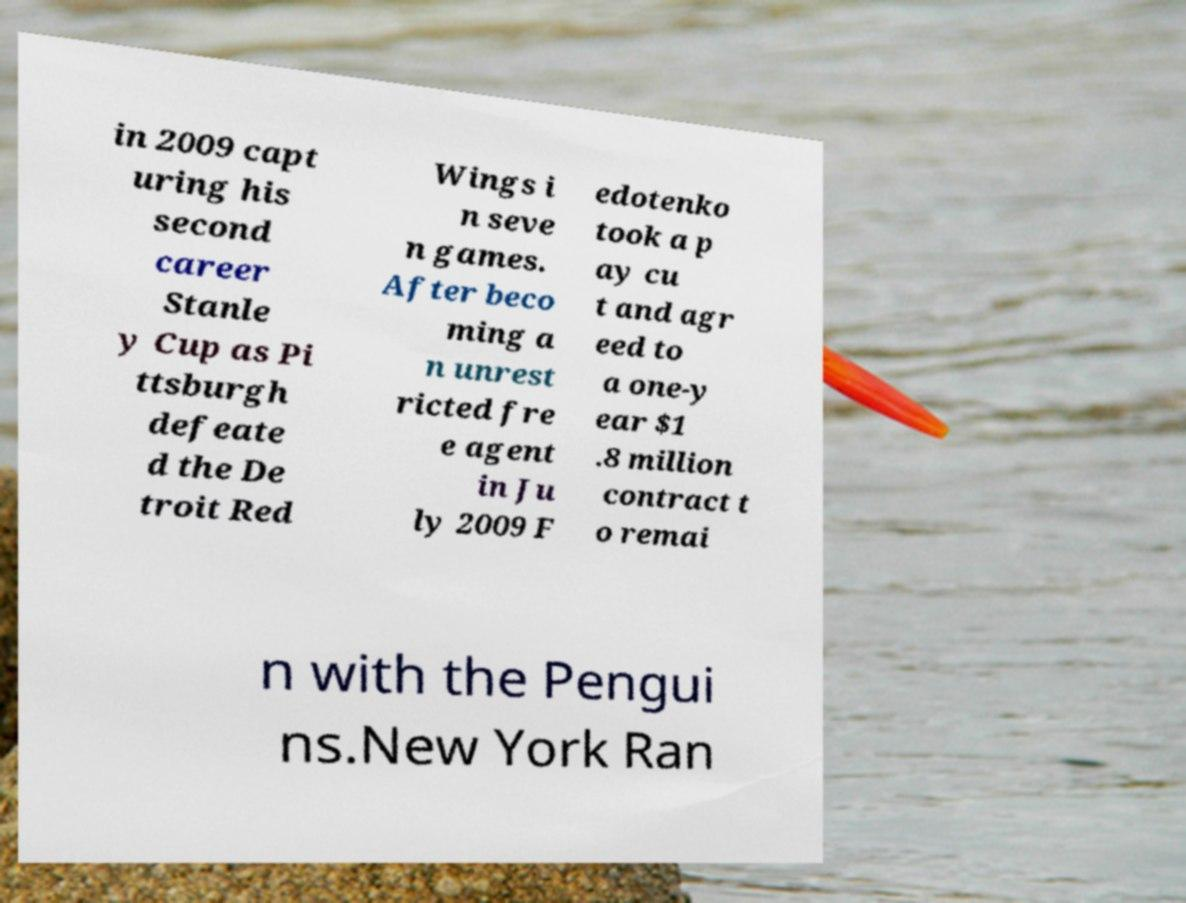Could you extract and type out the text from this image? in 2009 capt uring his second career Stanle y Cup as Pi ttsburgh defeate d the De troit Red Wings i n seve n games. After beco ming a n unrest ricted fre e agent in Ju ly 2009 F edotenko took a p ay cu t and agr eed to a one-y ear $1 .8 million contract t o remai n with the Pengui ns.New York Ran 